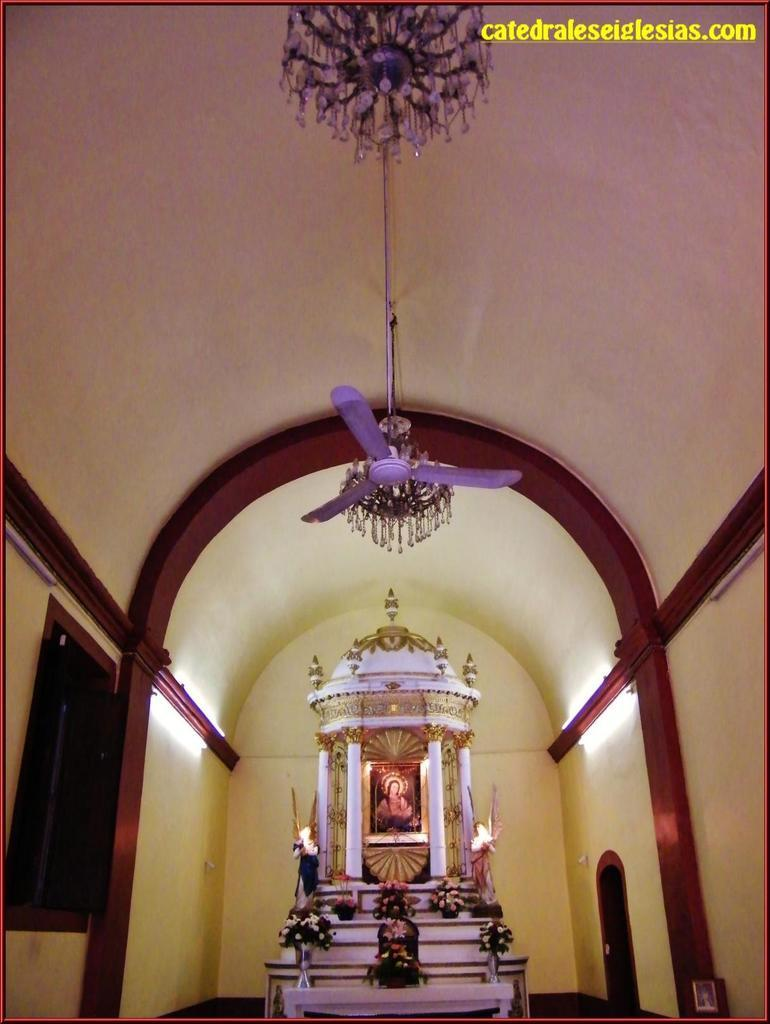What is the shape of the roof in the room depicted in the image? The roof in the room has a curved shape. What is hanging from the roof in the image? There is a chandelier and a fan hanging from the roof in the image. What type of structure is present in the room? There is a pillar tomb in the room. What is placed inside the tomb? A photo is present inside the tomb. What is placed in front of the tomb? Flowers are placed in front of the tomb. What type of vessel is used to store the flowers in the image? There is no vessel present in the image to store the flowers; they are simply placed in front of the tomb. 